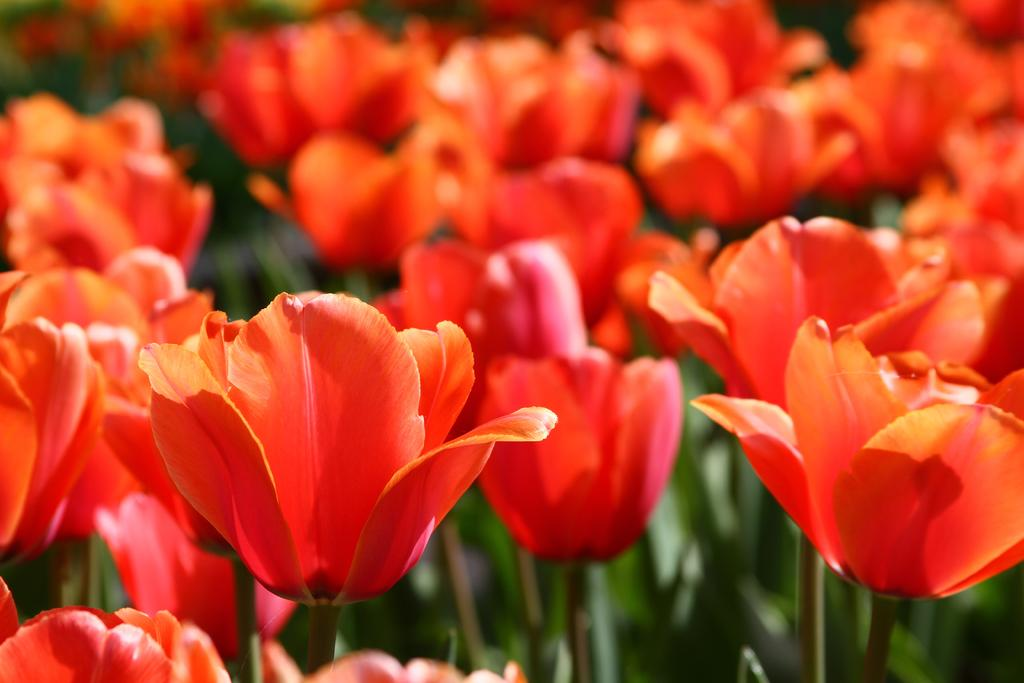What type of living organisms can be seen in the image? Flowers are visible in the image. What type of leather material is covering the scarecrow in the image? There is no scarecrow present in the image, and therefore no leather material can be observed. 